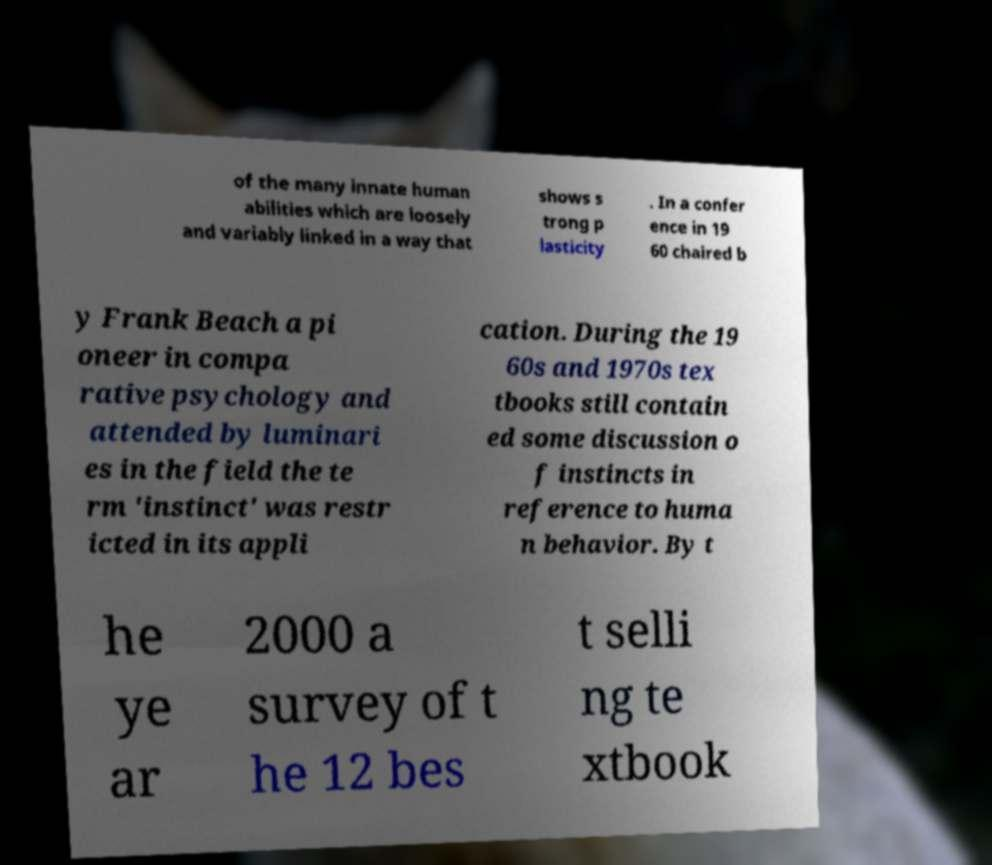What messages or text are displayed in this image? I need them in a readable, typed format. of the many innate human abilities which are loosely and variably linked in a way that shows s trong p lasticity . In a confer ence in 19 60 chaired b y Frank Beach a pi oneer in compa rative psychology and attended by luminari es in the field the te rm 'instinct' was restr icted in its appli cation. During the 19 60s and 1970s tex tbooks still contain ed some discussion o f instincts in reference to huma n behavior. By t he ye ar 2000 a survey of t he 12 bes t selli ng te xtbook 